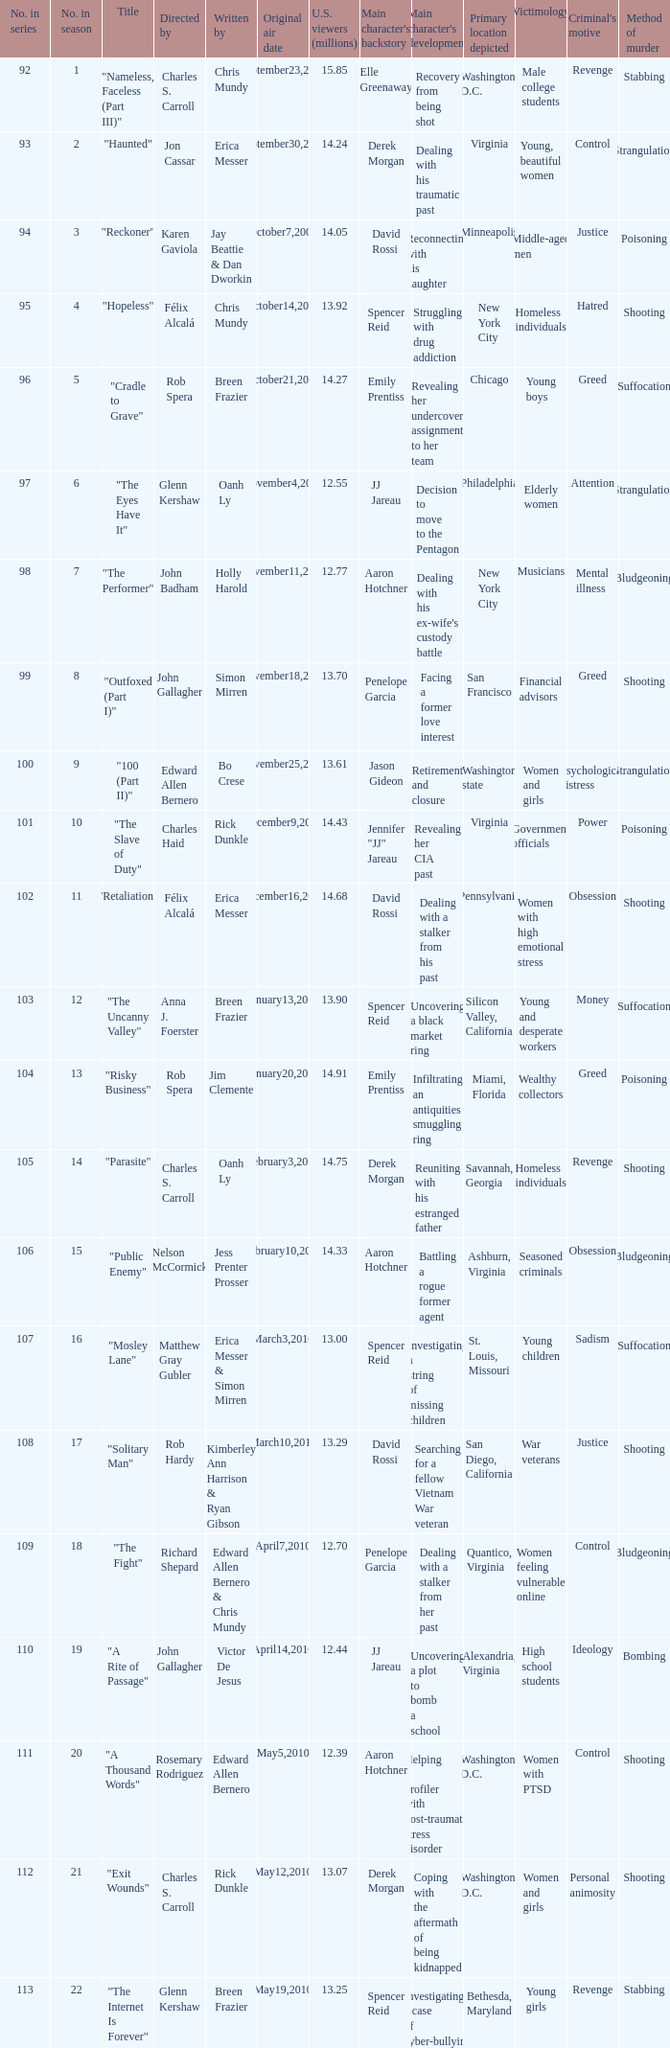In which season was the episode "haunted" featured? 2.0. 